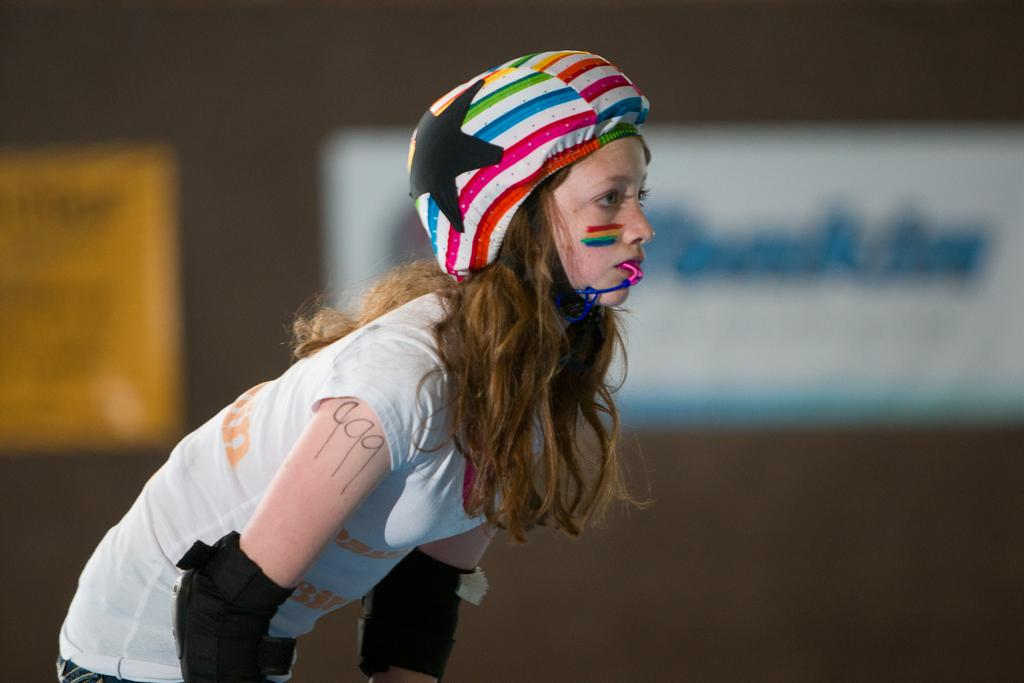Who is present in the image? There is a woman in the image. What is the woman wearing on her head? The woman is wearing a helmet. What color is the woman's t-shirt? The woman is wearing a white color t-shirt. What protective gear is the woman wearing on her elbows? The woman is wearing elbow pads. How would you describe the background of the image? The background of the image is blurred. What type of quilt is the woman using to cover her face in the image? There is no quilt present in the image, and the woman is not using any object to cover her face. 